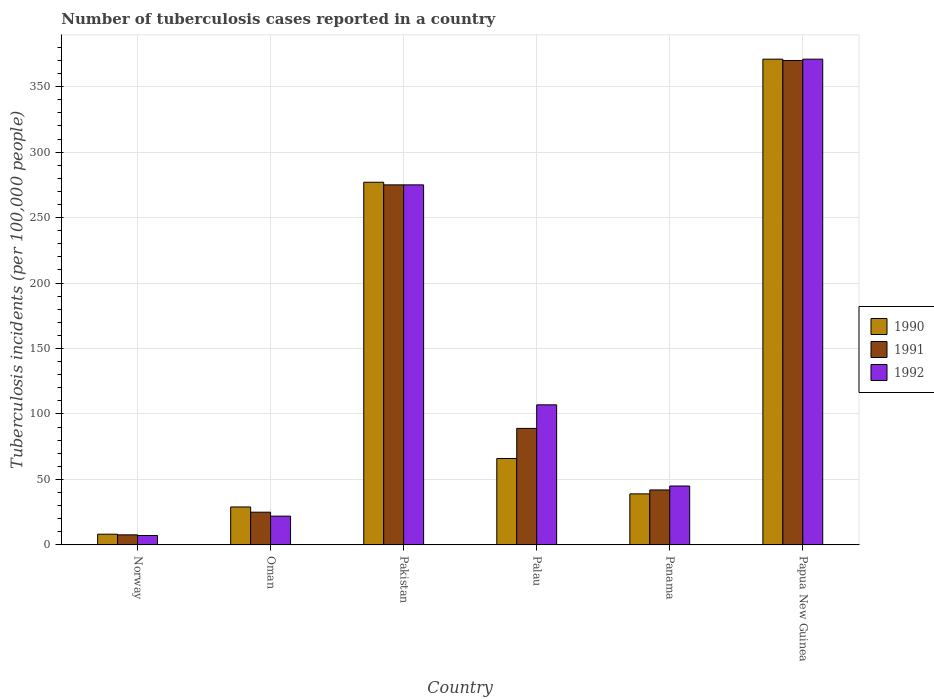How many different coloured bars are there?
Offer a very short reply. 3. How many groups of bars are there?
Provide a short and direct response. 6. Are the number of bars on each tick of the X-axis equal?
Offer a very short reply. Yes. How many bars are there on the 5th tick from the left?
Ensure brevity in your answer.  3. How many bars are there on the 4th tick from the right?
Provide a short and direct response. 3. What is the label of the 4th group of bars from the left?
Your response must be concise. Palau. Across all countries, what is the maximum number of tuberculosis cases reported in in 1990?
Ensure brevity in your answer.  371. In which country was the number of tuberculosis cases reported in in 1990 maximum?
Your answer should be compact. Papua New Guinea. In which country was the number of tuberculosis cases reported in in 1991 minimum?
Provide a succinct answer. Norway. What is the total number of tuberculosis cases reported in in 1992 in the graph?
Ensure brevity in your answer.  827.2. What is the difference between the number of tuberculosis cases reported in in 1992 in Pakistan and that in Panama?
Keep it short and to the point. 230. What is the difference between the number of tuberculosis cases reported in in 1991 in Norway and the number of tuberculosis cases reported in in 1992 in Papua New Guinea?
Give a very brief answer. -363.3. What is the average number of tuberculosis cases reported in in 1990 per country?
Provide a short and direct response. 131.7. What is the difference between the number of tuberculosis cases reported in of/in 1990 and number of tuberculosis cases reported in of/in 1991 in Oman?
Your answer should be compact. 4. In how many countries, is the number of tuberculosis cases reported in in 1992 greater than 170?
Your response must be concise. 2. What is the ratio of the number of tuberculosis cases reported in in 1991 in Norway to that in Panama?
Your answer should be compact. 0.18. Is the difference between the number of tuberculosis cases reported in in 1990 in Norway and Palau greater than the difference between the number of tuberculosis cases reported in in 1991 in Norway and Palau?
Ensure brevity in your answer.  Yes. What is the difference between the highest and the second highest number of tuberculosis cases reported in in 1991?
Ensure brevity in your answer.  -281. What is the difference between the highest and the lowest number of tuberculosis cases reported in in 1991?
Your response must be concise. 362.3. What does the 2nd bar from the right in Pakistan represents?
Offer a terse response. 1991. Is it the case that in every country, the sum of the number of tuberculosis cases reported in in 1991 and number of tuberculosis cases reported in in 1992 is greater than the number of tuberculosis cases reported in in 1990?
Ensure brevity in your answer.  Yes. How many bars are there?
Ensure brevity in your answer.  18. Are all the bars in the graph horizontal?
Keep it short and to the point. No. Does the graph contain grids?
Your answer should be compact. Yes. Where does the legend appear in the graph?
Your answer should be very brief. Center right. What is the title of the graph?
Provide a succinct answer. Number of tuberculosis cases reported in a country. Does "2014" appear as one of the legend labels in the graph?
Provide a short and direct response. No. What is the label or title of the X-axis?
Your answer should be compact. Country. What is the label or title of the Y-axis?
Your response must be concise. Tuberculosis incidents (per 100,0 people). What is the Tuberculosis incidents (per 100,000 people) of 1991 in Norway?
Ensure brevity in your answer.  7.7. What is the Tuberculosis incidents (per 100,000 people) of 1990 in Pakistan?
Your answer should be compact. 277. What is the Tuberculosis incidents (per 100,000 people) in 1991 in Pakistan?
Ensure brevity in your answer.  275. What is the Tuberculosis incidents (per 100,000 people) of 1992 in Pakistan?
Your answer should be compact. 275. What is the Tuberculosis incidents (per 100,000 people) of 1990 in Palau?
Offer a terse response. 66. What is the Tuberculosis incidents (per 100,000 people) in 1991 in Palau?
Keep it short and to the point. 89. What is the Tuberculosis incidents (per 100,000 people) in 1992 in Palau?
Your answer should be very brief. 107. What is the Tuberculosis incidents (per 100,000 people) in 1992 in Panama?
Provide a succinct answer. 45. What is the Tuberculosis incidents (per 100,000 people) in 1990 in Papua New Guinea?
Provide a short and direct response. 371. What is the Tuberculosis incidents (per 100,000 people) of 1991 in Papua New Guinea?
Provide a short and direct response. 370. What is the Tuberculosis incidents (per 100,000 people) in 1992 in Papua New Guinea?
Offer a very short reply. 371. Across all countries, what is the maximum Tuberculosis incidents (per 100,000 people) in 1990?
Ensure brevity in your answer.  371. Across all countries, what is the maximum Tuberculosis incidents (per 100,000 people) in 1991?
Make the answer very short. 370. Across all countries, what is the maximum Tuberculosis incidents (per 100,000 people) of 1992?
Your response must be concise. 371. Across all countries, what is the minimum Tuberculosis incidents (per 100,000 people) in 1990?
Your answer should be very brief. 8.2. Across all countries, what is the minimum Tuberculosis incidents (per 100,000 people) in 1991?
Provide a short and direct response. 7.7. What is the total Tuberculosis incidents (per 100,000 people) of 1990 in the graph?
Keep it short and to the point. 790.2. What is the total Tuberculosis incidents (per 100,000 people) in 1991 in the graph?
Make the answer very short. 808.7. What is the total Tuberculosis incidents (per 100,000 people) of 1992 in the graph?
Provide a short and direct response. 827.2. What is the difference between the Tuberculosis incidents (per 100,000 people) of 1990 in Norway and that in Oman?
Give a very brief answer. -20.8. What is the difference between the Tuberculosis incidents (per 100,000 people) in 1991 in Norway and that in Oman?
Your answer should be compact. -17.3. What is the difference between the Tuberculosis incidents (per 100,000 people) of 1992 in Norway and that in Oman?
Ensure brevity in your answer.  -14.8. What is the difference between the Tuberculosis incidents (per 100,000 people) in 1990 in Norway and that in Pakistan?
Provide a succinct answer. -268.8. What is the difference between the Tuberculosis incidents (per 100,000 people) of 1991 in Norway and that in Pakistan?
Keep it short and to the point. -267.3. What is the difference between the Tuberculosis incidents (per 100,000 people) in 1992 in Norway and that in Pakistan?
Keep it short and to the point. -267.8. What is the difference between the Tuberculosis incidents (per 100,000 people) of 1990 in Norway and that in Palau?
Provide a succinct answer. -57.8. What is the difference between the Tuberculosis incidents (per 100,000 people) of 1991 in Norway and that in Palau?
Give a very brief answer. -81.3. What is the difference between the Tuberculosis incidents (per 100,000 people) in 1992 in Norway and that in Palau?
Provide a short and direct response. -99.8. What is the difference between the Tuberculosis incidents (per 100,000 people) of 1990 in Norway and that in Panama?
Keep it short and to the point. -30.8. What is the difference between the Tuberculosis incidents (per 100,000 people) in 1991 in Norway and that in Panama?
Your answer should be very brief. -34.3. What is the difference between the Tuberculosis incidents (per 100,000 people) of 1992 in Norway and that in Panama?
Offer a terse response. -37.8. What is the difference between the Tuberculosis incidents (per 100,000 people) in 1990 in Norway and that in Papua New Guinea?
Keep it short and to the point. -362.8. What is the difference between the Tuberculosis incidents (per 100,000 people) of 1991 in Norway and that in Papua New Guinea?
Offer a terse response. -362.3. What is the difference between the Tuberculosis incidents (per 100,000 people) of 1992 in Norway and that in Papua New Guinea?
Your answer should be very brief. -363.8. What is the difference between the Tuberculosis incidents (per 100,000 people) of 1990 in Oman and that in Pakistan?
Keep it short and to the point. -248. What is the difference between the Tuberculosis incidents (per 100,000 people) in 1991 in Oman and that in Pakistan?
Ensure brevity in your answer.  -250. What is the difference between the Tuberculosis incidents (per 100,000 people) in 1992 in Oman and that in Pakistan?
Your answer should be very brief. -253. What is the difference between the Tuberculosis incidents (per 100,000 people) in 1990 in Oman and that in Palau?
Make the answer very short. -37. What is the difference between the Tuberculosis incidents (per 100,000 people) in 1991 in Oman and that in Palau?
Ensure brevity in your answer.  -64. What is the difference between the Tuberculosis incidents (per 100,000 people) in 1992 in Oman and that in Palau?
Ensure brevity in your answer.  -85. What is the difference between the Tuberculosis incidents (per 100,000 people) in 1990 in Oman and that in Papua New Guinea?
Offer a very short reply. -342. What is the difference between the Tuberculosis incidents (per 100,000 people) in 1991 in Oman and that in Papua New Guinea?
Provide a succinct answer. -345. What is the difference between the Tuberculosis incidents (per 100,000 people) of 1992 in Oman and that in Papua New Guinea?
Give a very brief answer. -349. What is the difference between the Tuberculosis incidents (per 100,000 people) of 1990 in Pakistan and that in Palau?
Give a very brief answer. 211. What is the difference between the Tuberculosis incidents (per 100,000 people) of 1991 in Pakistan and that in Palau?
Your answer should be compact. 186. What is the difference between the Tuberculosis incidents (per 100,000 people) in 1992 in Pakistan and that in Palau?
Offer a very short reply. 168. What is the difference between the Tuberculosis incidents (per 100,000 people) in 1990 in Pakistan and that in Panama?
Your response must be concise. 238. What is the difference between the Tuberculosis incidents (per 100,000 people) of 1991 in Pakistan and that in Panama?
Keep it short and to the point. 233. What is the difference between the Tuberculosis incidents (per 100,000 people) in 1992 in Pakistan and that in Panama?
Make the answer very short. 230. What is the difference between the Tuberculosis incidents (per 100,000 people) of 1990 in Pakistan and that in Papua New Guinea?
Provide a succinct answer. -94. What is the difference between the Tuberculosis incidents (per 100,000 people) in 1991 in Pakistan and that in Papua New Guinea?
Your response must be concise. -95. What is the difference between the Tuberculosis incidents (per 100,000 people) of 1992 in Pakistan and that in Papua New Guinea?
Your answer should be compact. -96. What is the difference between the Tuberculosis incidents (per 100,000 people) in 1990 in Palau and that in Panama?
Your answer should be very brief. 27. What is the difference between the Tuberculosis incidents (per 100,000 people) in 1990 in Palau and that in Papua New Guinea?
Make the answer very short. -305. What is the difference between the Tuberculosis incidents (per 100,000 people) in 1991 in Palau and that in Papua New Guinea?
Ensure brevity in your answer.  -281. What is the difference between the Tuberculosis incidents (per 100,000 people) of 1992 in Palau and that in Papua New Guinea?
Your response must be concise. -264. What is the difference between the Tuberculosis incidents (per 100,000 people) in 1990 in Panama and that in Papua New Guinea?
Keep it short and to the point. -332. What is the difference between the Tuberculosis incidents (per 100,000 people) in 1991 in Panama and that in Papua New Guinea?
Make the answer very short. -328. What is the difference between the Tuberculosis incidents (per 100,000 people) of 1992 in Panama and that in Papua New Guinea?
Your answer should be compact. -326. What is the difference between the Tuberculosis incidents (per 100,000 people) of 1990 in Norway and the Tuberculosis incidents (per 100,000 people) of 1991 in Oman?
Ensure brevity in your answer.  -16.8. What is the difference between the Tuberculosis incidents (per 100,000 people) in 1991 in Norway and the Tuberculosis incidents (per 100,000 people) in 1992 in Oman?
Ensure brevity in your answer.  -14.3. What is the difference between the Tuberculosis incidents (per 100,000 people) in 1990 in Norway and the Tuberculosis incidents (per 100,000 people) in 1991 in Pakistan?
Your answer should be compact. -266.8. What is the difference between the Tuberculosis incidents (per 100,000 people) of 1990 in Norway and the Tuberculosis incidents (per 100,000 people) of 1992 in Pakistan?
Make the answer very short. -266.8. What is the difference between the Tuberculosis incidents (per 100,000 people) in 1991 in Norway and the Tuberculosis incidents (per 100,000 people) in 1992 in Pakistan?
Give a very brief answer. -267.3. What is the difference between the Tuberculosis incidents (per 100,000 people) of 1990 in Norway and the Tuberculosis incidents (per 100,000 people) of 1991 in Palau?
Your answer should be compact. -80.8. What is the difference between the Tuberculosis incidents (per 100,000 people) of 1990 in Norway and the Tuberculosis incidents (per 100,000 people) of 1992 in Palau?
Provide a succinct answer. -98.8. What is the difference between the Tuberculosis incidents (per 100,000 people) in 1991 in Norway and the Tuberculosis incidents (per 100,000 people) in 1992 in Palau?
Offer a terse response. -99.3. What is the difference between the Tuberculosis incidents (per 100,000 people) in 1990 in Norway and the Tuberculosis incidents (per 100,000 people) in 1991 in Panama?
Keep it short and to the point. -33.8. What is the difference between the Tuberculosis incidents (per 100,000 people) of 1990 in Norway and the Tuberculosis incidents (per 100,000 people) of 1992 in Panama?
Provide a succinct answer. -36.8. What is the difference between the Tuberculosis incidents (per 100,000 people) of 1991 in Norway and the Tuberculosis incidents (per 100,000 people) of 1992 in Panama?
Ensure brevity in your answer.  -37.3. What is the difference between the Tuberculosis incidents (per 100,000 people) of 1990 in Norway and the Tuberculosis incidents (per 100,000 people) of 1991 in Papua New Guinea?
Your answer should be compact. -361.8. What is the difference between the Tuberculosis incidents (per 100,000 people) of 1990 in Norway and the Tuberculosis incidents (per 100,000 people) of 1992 in Papua New Guinea?
Provide a short and direct response. -362.8. What is the difference between the Tuberculosis incidents (per 100,000 people) in 1991 in Norway and the Tuberculosis incidents (per 100,000 people) in 1992 in Papua New Guinea?
Provide a short and direct response. -363.3. What is the difference between the Tuberculosis incidents (per 100,000 people) of 1990 in Oman and the Tuberculosis incidents (per 100,000 people) of 1991 in Pakistan?
Offer a terse response. -246. What is the difference between the Tuberculosis incidents (per 100,000 people) of 1990 in Oman and the Tuberculosis incidents (per 100,000 people) of 1992 in Pakistan?
Offer a very short reply. -246. What is the difference between the Tuberculosis incidents (per 100,000 people) of 1991 in Oman and the Tuberculosis incidents (per 100,000 people) of 1992 in Pakistan?
Provide a short and direct response. -250. What is the difference between the Tuberculosis incidents (per 100,000 people) of 1990 in Oman and the Tuberculosis incidents (per 100,000 people) of 1991 in Palau?
Offer a very short reply. -60. What is the difference between the Tuberculosis incidents (per 100,000 people) in 1990 in Oman and the Tuberculosis incidents (per 100,000 people) in 1992 in Palau?
Make the answer very short. -78. What is the difference between the Tuberculosis incidents (per 100,000 people) in 1991 in Oman and the Tuberculosis incidents (per 100,000 people) in 1992 in Palau?
Provide a succinct answer. -82. What is the difference between the Tuberculosis incidents (per 100,000 people) of 1991 in Oman and the Tuberculosis incidents (per 100,000 people) of 1992 in Panama?
Offer a terse response. -20. What is the difference between the Tuberculosis incidents (per 100,000 people) in 1990 in Oman and the Tuberculosis incidents (per 100,000 people) in 1991 in Papua New Guinea?
Give a very brief answer. -341. What is the difference between the Tuberculosis incidents (per 100,000 people) in 1990 in Oman and the Tuberculosis incidents (per 100,000 people) in 1992 in Papua New Guinea?
Your answer should be very brief. -342. What is the difference between the Tuberculosis incidents (per 100,000 people) in 1991 in Oman and the Tuberculosis incidents (per 100,000 people) in 1992 in Papua New Guinea?
Provide a short and direct response. -346. What is the difference between the Tuberculosis incidents (per 100,000 people) in 1990 in Pakistan and the Tuberculosis incidents (per 100,000 people) in 1991 in Palau?
Provide a short and direct response. 188. What is the difference between the Tuberculosis incidents (per 100,000 people) of 1990 in Pakistan and the Tuberculosis incidents (per 100,000 people) of 1992 in Palau?
Make the answer very short. 170. What is the difference between the Tuberculosis incidents (per 100,000 people) of 1991 in Pakistan and the Tuberculosis incidents (per 100,000 people) of 1992 in Palau?
Keep it short and to the point. 168. What is the difference between the Tuberculosis incidents (per 100,000 people) in 1990 in Pakistan and the Tuberculosis incidents (per 100,000 people) in 1991 in Panama?
Ensure brevity in your answer.  235. What is the difference between the Tuberculosis incidents (per 100,000 people) in 1990 in Pakistan and the Tuberculosis incidents (per 100,000 people) in 1992 in Panama?
Make the answer very short. 232. What is the difference between the Tuberculosis incidents (per 100,000 people) in 1991 in Pakistan and the Tuberculosis incidents (per 100,000 people) in 1992 in Panama?
Offer a very short reply. 230. What is the difference between the Tuberculosis incidents (per 100,000 people) of 1990 in Pakistan and the Tuberculosis incidents (per 100,000 people) of 1991 in Papua New Guinea?
Offer a very short reply. -93. What is the difference between the Tuberculosis incidents (per 100,000 people) in 1990 in Pakistan and the Tuberculosis incidents (per 100,000 people) in 1992 in Papua New Guinea?
Make the answer very short. -94. What is the difference between the Tuberculosis incidents (per 100,000 people) in 1991 in Pakistan and the Tuberculosis incidents (per 100,000 people) in 1992 in Papua New Guinea?
Keep it short and to the point. -96. What is the difference between the Tuberculosis incidents (per 100,000 people) in 1990 in Palau and the Tuberculosis incidents (per 100,000 people) in 1992 in Panama?
Your answer should be very brief. 21. What is the difference between the Tuberculosis incidents (per 100,000 people) in 1991 in Palau and the Tuberculosis incidents (per 100,000 people) in 1992 in Panama?
Your answer should be very brief. 44. What is the difference between the Tuberculosis incidents (per 100,000 people) of 1990 in Palau and the Tuberculosis incidents (per 100,000 people) of 1991 in Papua New Guinea?
Your response must be concise. -304. What is the difference between the Tuberculosis incidents (per 100,000 people) in 1990 in Palau and the Tuberculosis incidents (per 100,000 people) in 1992 in Papua New Guinea?
Provide a succinct answer. -305. What is the difference between the Tuberculosis incidents (per 100,000 people) in 1991 in Palau and the Tuberculosis incidents (per 100,000 people) in 1992 in Papua New Guinea?
Give a very brief answer. -282. What is the difference between the Tuberculosis incidents (per 100,000 people) of 1990 in Panama and the Tuberculosis incidents (per 100,000 people) of 1991 in Papua New Guinea?
Offer a terse response. -331. What is the difference between the Tuberculosis incidents (per 100,000 people) of 1990 in Panama and the Tuberculosis incidents (per 100,000 people) of 1992 in Papua New Guinea?
Your response must be concise. -332. What is the difference between the Tuberculosis incidents (per 100,000 people) in 1991 in Panama and the Tuberculosis incidents (per 100,000 people) in 1992 in Papua New Guinea?
Offer a very short reply. -329. What is the average Tuberculosis incidents (per 100,000 people) in 1990 per country?
Offer a very short reply. 131.7. What is the average Tuberculosis incidents (per 100,000 people) of 1991 per country?
Give a very brief answer. 134.78. What is the average Tuberculosis incidents (per 100,000 people) in 1992 per country?
Provide a short and direct response. 137.87. What is the difference between the Tuberculosis incidents (per 100,000 people) of 1990 and Tuberculosis incidents (per 100,000 people) of 1991 in Norway?
Offer a terse response. 0.5. What is the difference between the Tuberculosis incidents (per 100,000 people) in 1991 and Tuberculosis incidents (per 100,000 people) in 1992 in Oman?
Ensure brevity in your answer.  3. What is the difference between the Tuberculosis incidents (per 100,000 people) in 1990 and Tuberculosis incidents (per 100,000 people) in 1991 in Pakistan?
Your response must be concise. 2. What is the difference between the Tuberculosis incidents (per 100,000 people) in 1990 and Tuberculosis incidents (per 100,000 people) in 1992 in Pakistan?
Keep it short and to the point. 2. What is the difference between the Tuberculosis incidents (per 100,000 people) in 1990 and Tuberculosis incidents (per 100,000 people) in 1991 in Palau?
Give a very brief answer. -23. What is the difference between the Tuberculosis incidents (per 100,000 people) of 1990 and Tuberculosis incidents (per 100,000 people) of 1992 in Palau?
Your answer should be very brief. -41. What is the difference between the Tuberculosis incidents (per 100,000 people) of 1990 and Tuberculosis incidents (per 100,000 people) of 1991 in Panama?
Give a very brief answer. -3. What is the difference between the Tuberculosis incidents (per 100,000 people) of 1990 and Tuberculosis incidents (per 100,000 people) of 1992 in Papua New Guinea?
Give a very brief answer. 0. What is the ratio of the Tuberculosis incidents (per 100,000 people) of 1990 in Norway to that in Oman?
Provide a short and direct response. 0.28. What is the ratio of the Tuberculosis incidents (per 100,000 people) in 1991 in Norway to that in Oman?
Offer a very short reply. 0.31. What is the ratio of the Tuberculosis incidents (per 100,000 people) in 1992 in Norway to that in Oman?
Provide a short and direct response. 0.33. What is the ratio of the Tuberculosis incidents (per 100,000 people) in 1990 in Norway to that in Pakistan?
Keep it short and to the point. 0.03. What is the ratio of the Tuberculosis incidents (per 100,000 people) of 1991 in Norway to that in Pakistan?
Give a very brief answer. 0.03. What is the ratio of the Tuberculosis incidents (per 100,000 people) of 1992 in Norway to that in Pakistan?
Your answer should be very brief. 0.03. What is the ratio of the Tuberculosis incidents (per 100,000 people) of 1990 in Norway to that in Palau?
Your answer should be very brief. 0.12. What is the ratio of the Tuberculosis incidents (per 100,000 people) of 1991 in Norway to that in Palau?
Your answer should be very brief. 0.09. What is the ratio of the Tuberculosis incidents (per 100,000 people) in 1992 in Norway to that in Palau?
Give a very brief answer. 0.07. What is the ratio of the Tuberculosis incidents (per 100,000 people) in 1990 in Norway to that in Panama?
Your response must be concise. 0.21. What is the ratio of the Tuberculosis incidents (per 100,000 people) in 1991 in Norway to that in Panama?
Your response must be concise. 0.18. What is the ratio of the Tuberculosis incidents (per 100,000 people) of 1992 in Norway to that in Panama?
Make the answer very short. 0.16. What is the ratio of the Tuberculosis incidents (per 100,000 people) in 1990 in Norway to that in Papua New Guinea?
Offer a very short reply. 0.02. What is the ratio of the Tuberculosis incidents (per 100,000 people) of 1991 in Norway to that in Papua New Guinea?
Provide a short and direct response. 0.02. What is the ratio of the Tuberculosis incidents (per 100,000 people) in 1992 in Norway to that in Papua New Guinea?
Make the answer very short. 0.02. What is the ratio of the Tuberculosis incidents (per 100,000 people) of 1990 in Oman to that in Pakistan?
Offer a terse response. 0.1. What is the ratio of the Tuberculosis incidents (per 100,000 people) of 1991 in Oman to that in Pakistan?
Provide a short and direct response. 0.09. What is the ratio of the Tuberculosis incidents (per 100,000 people) in 1990 in Oman to that in Palau?
Provide a short and direct response. 0.44. What is the ratio of the Tuberculosis incidents (per 100,000 people) of 1991 in Oman to that in Palau?
Provide a succinct answer. 0.28. What is the ratio of the Tuberculosis incidents (per 100,000 people) of 1992 in Oman to that in Palau?
Offer a very short reply. 0.21. What is the ratio of the Tuberculosis incidents (per 100,000 people) of 1990 in Oman to that in Panama?
Make the answer very short. 0.74. What is the ratio of the Tuberculosis incidents (per 100,000 people) in 1991 in Oman to that in Panama?
Your response must be concise. 0.6. What is the ratio of the Tuberculosis incidents (per 100,000 people) in 1992 in Oman to that in Panama?
Provide a succinct answer. 0.49. What is the ratio of the Tuberculosis incidents (per 100,000 people) of 1990 in Oman to that in Papua New Guinea?
Ensure brevity in your answer.  0.08. What is the ratio of the Tuberculosis incidents (per 100,000 people) of 1991 in Oman to that in Papua New Guinea?
Provide a short and direct response. 0.07. What is the ratio of the Tuberculosis incidents (per 100,000 people) of 1992 in Oman to that in Papua New Guinea?
Your answer should be very brief. 0.06. What is the ratio of the Tuberculosis incidents (per 100,000 people) of 1990 in Pakistan to that in Palau?
Offer a terse response. 4.2. What is the ratio of the Tuberculosis incidents (per 100,000 people) of 1991 in Pakistan to that in Palau?
Ensure brevity in your answer.  3.09. What is the ratio of the Tuberculosis incidents (per 100,000 people) in 1992 in Pakistan to that in Palau?
Provide a short and direct response. 2.57. What is the ratio of the Tuberculosis incidents (per 100,000 people) of 1990 in Pakistan to that in Panama?
Your answer should be very brief. 7.1. What is the ratio of the Tuberculosis incidents (per 100,000 people) of 1991 in Pakistan to that in Panama?
Your answer should be very brief. 6.55. What is the ratio of the Tuberculosis incidents (per 100,000 people) in 1992 in Pakistan to that in Panama?
Offer a very short reply. 6.11. What is the ratio of the Tuberculosis incidents (per 100,000 people) of 1990 in Pakistan to that in Papua New Guinea?
Keep it short and to the point. 0.75. What is the ratio of the Tuberculosis incidents (per 100,000 people) in 1991 in Pakistan to that in Papua New Guinea?
Ensure brevity in your answer.  0.74. What is the ratio of the Tuberculosis incidents (per 100,000 people) of 1992 in Pakistan to that in Papua New Guinea?
Give a very brief answer. 0.74. What is the ratio of the Tuberculosis incidents (per 100,000 people) of 1990 in Palau to that in Panama?
Your answer should be very brief. 1.69. What is the ratio of the Tuberculosis incidents (per 100,000 people) in 1991 in Palau to that in Panama?
Offer a very short reply. 2.12. What is the ratio of the Tuberculosis incidents (per 100,000 people) in 1992 in Palau to that in Panama?
Provide a succinct answer. 2.38. What is the ratio of the Tuberculosis incidents (per 100,000 people) in 1990 in Palau to that in Papua New Guinea?
Your answer should be very brief. 0.18. What is the ratio of the Tuberculosis incidents (per 100,000 people) in 1991 in Palau to that in Papua New Guinea?
Your answer should be very brief. 0.24. What is the ratio of the Tuberculosis incidents (per 100,000 people) of 1992 in Palau to that in Papua New Guinea?
Your response must be concise. 0.29. What is the ratio of the Tuberculosis incidents (per 100,000 people) in 1990 in Panama to that in Papua New Guinea?
Offer a very short reply. 0.11. What is the ratio of the Tuberculosis incidents (per 100,000 people) of 1991 in Panama to that in Papua New Guinea?
Keep it short and to the point. 0.11. What is the ratio of the Tuberculosis incidents (per 100,000 people) of 1992 in Panama to that in Papua New Guinea?
Ensure brevity in your answer.  0.12. What is the difference between the highest and the second highest Tuberculosis incidents (per 100,000 people) in 1990?
Give a very brief answer. 94. What is the difference between the highest and the second highest Tuberculosis incidents (per 100,000 people) of 1992?
Provide a short and direct response. 96. What is the difference between the highest and the lowest Tuberculosis incidents (per 100,000 people) of 1990?
Your response must be concise. 362.8. What is the difference between the highest and the lowest Tuberculosis incidents (per 100,000 people) of 1991?
Your answer should be compact. 362.3. What is the difference between the highest and the lowest Tuberculosis incidents (per 100,000 people) in 1992?
Provide a short and direct response. 363.8. 